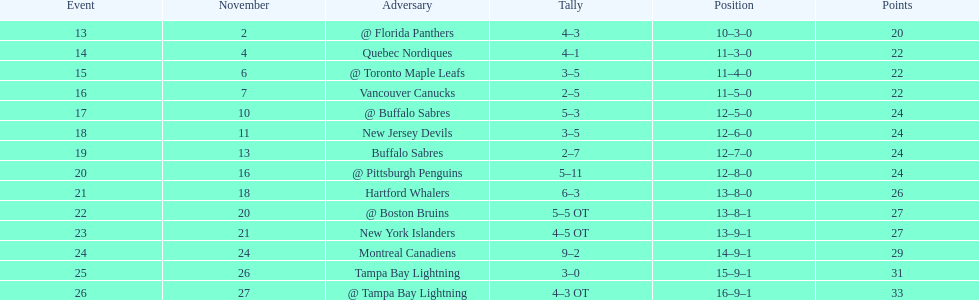What was the total penalty minutes that dave brown had on the 1993-1994 flyers? 137. 